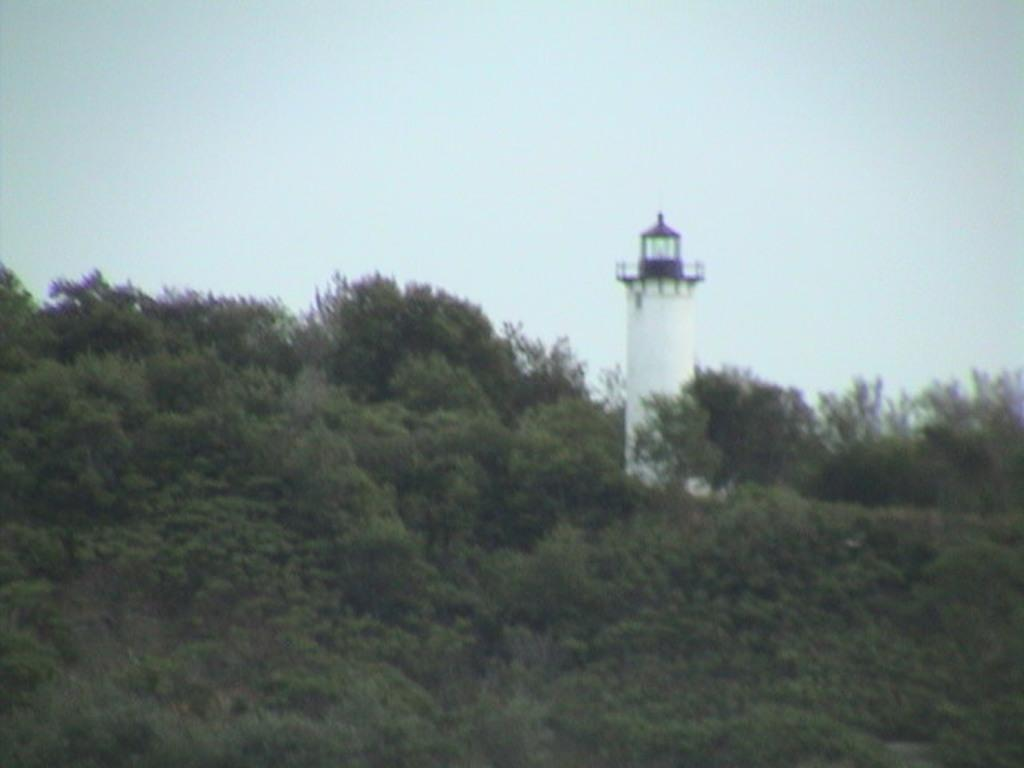What is the main structure in the image? There is a lighthouse in the image. Where is the lighthouse located? The lighthouse is on a mountain. What type of vegetation can be seen in the image? There are many trees in the image. What is visible at the top of the image? The sky is visible at the top of the image. What type of plastic material can be seen in the image? There is no plastic material present in the image. 